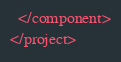<code> <loc_0><loc_0><loc_500><loc_500><_XML_>  </component>
</project></code> 